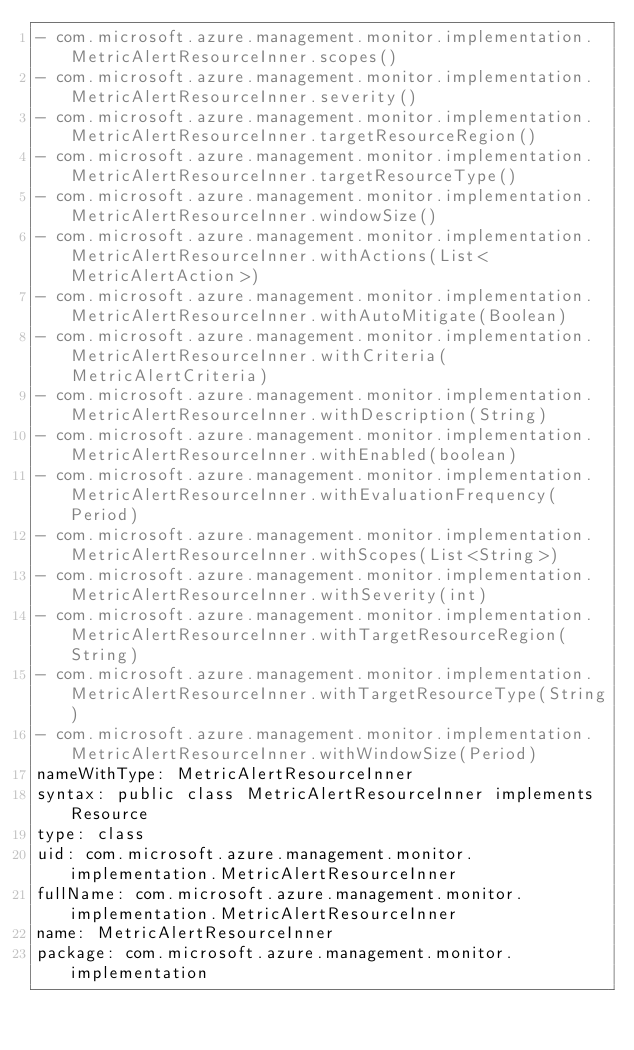<code> <loc_0><loc_0><loc_500><loc_500><_YAML_>- com.microsoft.azure.management.monitor.implementation.MetricAlertResourceInner.scopes()
- com.microsoft.azure.management.monitor.implementation.MetricAlertResourceInner.severity()
- com.microsoft.azure.management.monitor.implementation.MetricAlertResourceInner.targetResourceRegion()
- com.microsoft.azure.management.monitor.implementation.MetricAlertResourceInner.targetResourceType()
- com.microsoft.azure.management.monitor.implementation.MetricAlertResourceInner.windowSize()
- com.microsoft.azure.management.monitor.implementation.MetricAlertResourceInner.withActions(List<MetricAlertAction>)
- com.microsoft.azure.management.monitor.implementation.MetricAlertResourceInner.withAutoMitigate(Boolean)
- com.microsoft.azure.management.monitor.implementation.MetricAlertResourceInner.withCriteria(MetricAlertCriteria)
- com.microsoft.azure.management.monitor.implementation.MetricAlertResourceInner.withDescription(String)
- com.microsoft.azure.management.monitor.implementation.MetricAlertResourceInner.withEnabled(boolean)
- com.microsoft.azure.management.monitor.implementation.MetricAlertResourceInner.withEvaluationFrequency(Period)
- com.microsoft.azure.management.monitor.implementation.MetricAlertResourceInner.withScopes(List<String>)
- com.microsoft.azure.management.monitor.implementation.MetricAlertResourceInner.withSeverity(int)
- com.microsoft.azure.management.monitor.implementation.MetricAlertResourceInner.withTargetResourceRegion(String)
- com.microsoft.azure.management.monitor.implementation.MetricAlertResourceInner.withTargetResourceType(String)
- com.microsoft.azure.management.monitor.implementation.MetricAlertResourceInner.withWindowSize(Period)
nameWithType: MetricAlertResourceInner
syntax: public class MetricAlertResourceInner implements Resource
type: class
uid: com.microsoft.azure.management.monitor.implementation.MetricAlertResourceInner
fullName: com.microsoft.azure.management.monitor.implementation.MetricAlertResourceInner
name: MetricAlertResourceInner
package: com.microsoft.azure.management.monitor.implementation</code> 